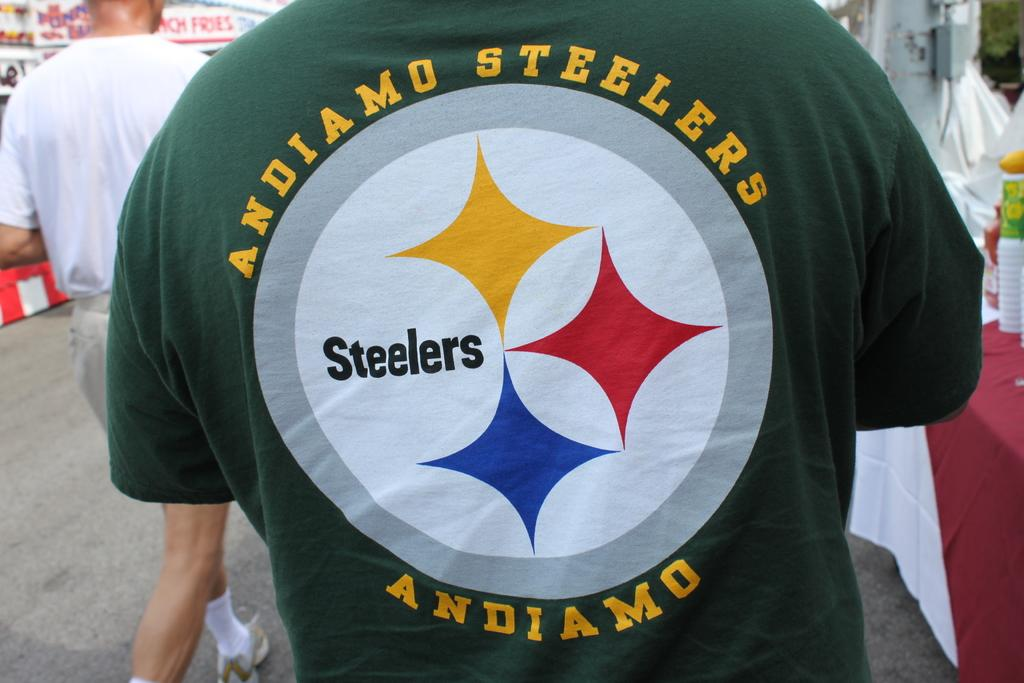<image>
Describe the image concisely. A man wears a green Andiamo Steelers shirt with a logo on back. 